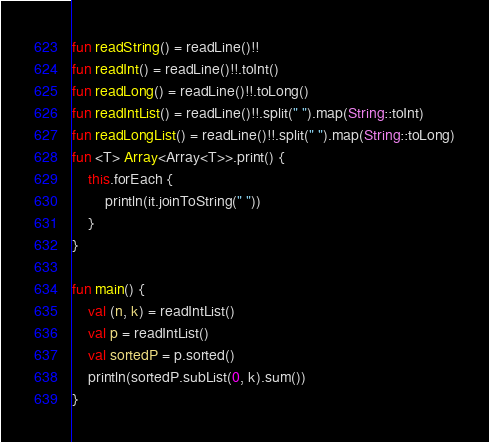<code> <loc_0><loc_0><loc_500><loc_500><_Kotlin_>fun readString() = readLine()!!
fun readInt() = readLine()!!.toInt()
fun readLong() = readLine()!!.toLong()
fun readIntList() = readLine()!!.split(" ").map(String::toInt)
fun readLongList() = readLine()!!.split(" ").map(String::toLong)
fun <T> Array<Array<T>>.print() {
    this.forEach {
        println(it.joinToString(" "))
    }
}

fun main() {
    val (n, k) = readIntList()
    val p = readIntList()
    val sortedP = p.sorted()
    println(sortedP.subList(0, k).sum())
}</code> 